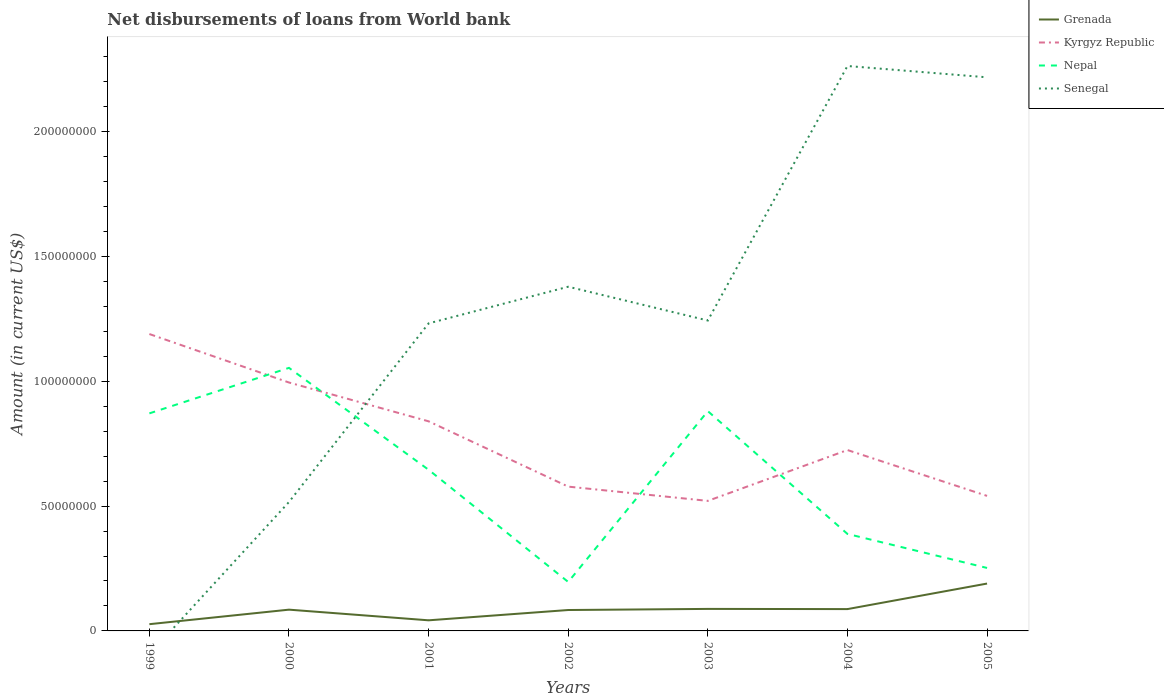Across all years, what is the maximum amount of loan disbursed from World Bank in Grenada?
Offer a very short reply. 2.70e+06. What is the total amount of loan disbursed from World Bank in Kyrgyz Republic in the graph?
Ensure brevity in your answer.  1.15e+07. What is the difference between the highest and the second highest amount of loan disbursed from World Bank in Grenada?
Offer a terse response. 1.63e+07. What is the difference between the highest and the lowest amount of loan disbursed from World Bank in Nepal?
Keep it short and to the point. 4. How many lines are there?
Ensure brevity in your answer.  4. How many years are there in the graph?
Provide a short and direct response. 7. What is the difference between two consecutive major ticks on the Y-axis?
Ensure brevity in your answer.  5.00e+07. Are the values on the major ticks of Y-axis written in scientific E-notation?
Your answer should be compact. No. Does the graph contain any zero values?
Ensure brevity in your answer.  Yes. Does the graph contain grids?
Provide a short and direct response. No. Where does the legend appear in the graph?
Offer a very short reply. Top right. How many legend labels are there?
Offer a terse response. 4. How are the legend labels stacked?
Provide a succinct answer. Vertical. What is the title of the graph?
Keep it short and to the point. Net disbursements of loans from World bank. What is the Amount (in current US$) of Grenada in 1999?
Provide a succinct answer. 2.70e+06. What is the Amount (in current US$) in Kyrgyz Republic in 1999?
Give a very brief answer. 1.19e+08. What is the Amount (in current US$) of Nepal in 1999?
Ensure brevity in your answer.  8.71e+07. What is the Amount (in current US$) in Senegal in 1999?
Your response must be concise. 0. What is the Amount (in current US$) in Grenada in 2000?
Provide a short and direct response. 8.52e+06. What is the Amount (in current US$) of Kyrgyz Republic in 2000?
Provide a succinct answer. 9.95e+07. What is the Amount (in current US$) of Nepal in 2000?
Your answer should be compact. 1.05e+08. What is the Amount (in current US$) of Senegal in 2000?
Offer a very short reply. 5.16e+07. What is the Amount (in current US$) of Grenada in 2001?
Keep it short and to the point. 4.25e+06. What is the Amount (in current US$) in Kyrgyz Republic in 2001?
Give a very brief answer. 8.40e+07. What is the Amount (in current US$) of Nepal in 2001?
Provide a succinct answer. 6.46e+07. What is the Amount (in current US$) in Senegal in 2001?
Make the answer very short. 1.23e+08. What is the Amount (in current US$) in Grenada in 2002?
Offer a terse response. 8.38e+06. What is the Amount (in current US$) of Kyrgyz Republic in 2002?
Your response must be concise. 5.78e+07. What is the Amount (in current US$) of Nepal in 2002?
Give a very brief answer. 1.96e+07. What is the Amount (in current US$) in Senegal in 2002?
Your answer should be very brief. 1.38e+08. What is the Amount (in current US$) in Grenada in 2003?
Offer a very short reply. 8.82e+06. What is the Amount (in current US$) of Kyrgyz Republic in 2003?
Your answer should be compact. 5.21e+07. What is the Amount (in current US$) in Nepal in 2003?
Your answer should be very brief. 8.80e+07. What is the Amount (in current US$) in Senegal in 2003?
Provide a short and direct response. 1.24e+08. What is the Amount (in current US$) in Grenada in 2004?
Offer a very short reply. 8.74e+06. What is the Amount (in current US$) of Kyrgyz Republic in 2004?
Ensure brevity in your answer.  7.25e+07. What is the Amount (in current US$) of Nepal in 2004?
Make the answer very short. 3.89e+07. What is the Amount (in current US$) in Senegal in 2004?
Give a very brief answer. 2.26e+08. What is the Amount (in current US$) of Grenada in 2005?
Provide a succinct answer. 1.90e+07. What is the Amount (in current US$) of Kyrgyz Republic in 2005?
Provide a succinct answer. 5.41e+07. What is the Amount (in current US$) of Nepal in 2005?
Your answer should be very brief. 2.52e+07. What is the Amount (in current US$) of Senegal in 2005?
Make the answer very short. 2.22e+08. Across all years, what is the maximum Amount (in current US$) of Grenada?
Keep it short and to the point. 1.90e+07. Across all years, what is the maximum Amount (in current US$) in Kyrgyz Republic?
Offer a very short reply. 1.19e+08. Across all years, what is the maximum Amount (in current US$) of Nepal?
Your answer should be compact. 1.05e+08. Across all years, what is the maximum Amount (in current US$) in Senegal?
Ensure brevity in your answer.  2.26e+08. Across all years, what is the minimum Amount (in current US$) of Grenada?
Give a very brief answer. 2.70e+06. Across all years, what is the minimum Amount (in current US$) in Kyrgyz Republic?
Your answer should be very brief. 5.21e+07. Across all years, what is the minimum Amount (in current US$) in Nepal?
Your response must be concise. 1.96e+07. What is the total Amount (in current US$) of Grenada in the graph?
Keep it short and to the point. 6.04e+07. What is the total Amount (in current US$) of Kyrgyz Republic in the graph?
Provide a short and direct response. 5.39e+08. What is the total Amount (in current US$) in Nepal in the graph?
Provide a short and direct response. 4.29e+08. What is the total Amount (in current US$) in Senegal in the graph?
Provide a short and direct response. 8.85e+08. What is the difference between the Amount (in current US$) in Grenada in 1999 and that in 2000?
Offer a very short reply. -5.82e+06. What is the difference between the Amount (in current US$) of Kyrgyz Republic in 1999 and that in 2000?
Offer a very short reply. 1.94e+07. What is the difference between the Amount (in current US$) of Nepal in 1999 and that in 2000?
Provide a short and direct response. -1.82e+07. What is the difference between the Amount (in current US$) of Grenada in 1999 and that in 2001?
Ensure brevity in your answer.  -1.55e+06. What is the difference between the Amount (in current US$) of Kyrgyz Republic in 1999 and that in 2001?
Make the answer very short. 3.50e+07. What is the difference between the Amount (in current US$) in Nepal in 1999 and that in 2001?
Ensure brevity in your answer.  2.26e+07. What is the difference between the Amount (in current US$) in Grenada in 1999 and that in 2002?
Give a very brief answer. -5.67e+06. What is the difference between the Amount (in current US$) in Kyrgyz Republic in 1999 and that in 2002?
Your response must be concise. 6.11e+07. What is the difference between the Amount (in current US$) in Nepal in 1999 and that in 2002?
Offer a very short reply. 6.75e+07. What is the difference between the Amount (in current US$) of Grenada in 1999 and that in 2003?
Provide a succinct answer. -6.12e+06. What is the difference between the Amount (in current US$) of Kyrgyz Republic in 1999 and that in 2003?
Your response must be concise. 6.68e+07. What is the difference between the Amount (in current US$) in Nepal in 1999 and that in 2003?
Give a very brief answer. -8.96e+05. What is the difference between the Amount (in current US$) in Grenada in 1999 and that in 2004?
Your answer should be compact. -6.04e+06. What is the difference between the Amount (in current US$) in Kyrgyz Republic in 1999 and that in 2004?
Keep it short and to the point. 4.65e+07. What is the difference between the Amount (in current US$) of Nepal in 1999 and that in 2004?
Your response must be concise. 4.83e+07. What is the difference between the Amount (in current US$) of Grenada in 1999 and that in 2005?
Your answer should be very brief. -1.63e+07. What is the difference between the Amount (in current US$) in Kyrgyz Republic in 1999 and that in 2005?
Offer a very short reply. 6.48e+07. What is the difference between the Amount (in current US$) in Nepal in 1999 and that in 2005?
Make the answer very short. 6.19e+07. What is the difference between the Amount (in current US$) of Grenada in 2000 and that in 2001?
Your response must be concise. 4.27e+06. What is the difference between the Amount (in current US$) of Kyrgyz Republic in 2000 and that in 2001?
Your response must be concise. 1.55e+07. What is the difference between the Amount (in current US$) of Nepal in 2000 and that in 2001?
Your answer should be compact. 4.08e+07. What is the difference between the Amount (in current US$) in Senegal in 2000 and that in 2001?
Your response must be concise. -7.16e+07. What is the difference between the Amount (in current US$) in Grenada in 2000 and that in 2002?
Make the answer very short. 1.44e+05. What is the difference between the Amount (in current US$) of Kyrgyz Republic in 2000 and that in 2002?
Your answer should be very brief. 4.17e+07. What is the difference between the Amount (in current US$) of Nepal in 2000 and that in 2002?
Ensure brevity in your answer.  8.58e+07. What is the difference between the Amount (in current US$) of Senegal in 2000 and that in 2002?
Offer a very short reply. -8.62e+07. What is the difference between the Amount (in current US$) in Grenada in 2000 and that in 2003?
Offer a very short reply. -2.98e+05. What is the difference between the Amount (in current US$) in Kyrgyz Republic in 2000 and that in 2003?
Offer a very short reply. 4.74e+07. What is the difference between the Amount (in current US$) of Nepal in 2000 and that in 2003?
Give a very brief answer. 1.73e+07. What is the difference between the Amount (in current US$) of Senegal in 2000 and that in 2003?
Offer a very short reply. -7.27e+07. What is the difference between the Amount (in current US$) in Grenada in 2000 and that in 2004?
Offer a terse response. -2.22e+05. What is the difference between the Amount (in current US$) in Kyrgyz Republic in 2000 and that in 2004?
Give a very brief answer. 2.70e+07. What is the difference between the Amount (in current US$) of Nepal in 2000 and that in 2004?
Provide a short and direct response. 6.65e+07. What is the difference between the Amount (in current US$) in Senegal in 2000 and that in 2004?
Ensure brevity in your answer.  -1.75e+08. What is the difference between the Amount (in current US$) of Grenada in 2000 and that in 2005?
Make the answer very short. -1.05e+07. What is the difference between the Amount (in current US$) of Kyrgyz Republic in 2000 and that in 2005?
Your answer should be very brief. 4.54e+07. What is the difference between the Amount (in current US$) of Nepal in 2000 and that in 2005?
Offer a very short reply. 8.02e+07. What is the difference between the Amount (in current US$) in Senegal in 2000 and that in 2005?
Offer a very short reply. -1.70e+08. What is the difference between the Amount (in current US$) of Grenada in 2001 and that in 2002?
Your answer should be compact. -4.12e+06. What is the difference between the Amount (in current US$) in Kyrgyz Republic in 2001 and that in 2002?
Keep it short and to the point. 2.62e+07. What is the difference between the Amount (in current US$) in Nepal in 2001 and that in 2002?
Your response must be concise. 4.49e+07. What is the difference between the Amount (in current US$) of Senegal in 2001 and that in 2002?
Provide a succinct answer. -1.47e+07. What is the difference between the Amount (in current US$) of Grenada in 2001 and that in 2003?
Your answer should be very brief. -4.57e+06. What is the difference between the Amount (in current US$) in Kyrgyz Republic in 2001 and that in 2003?
Offer a terse response. 3.19e+07. What is the difference between the Amount (in current US$) in Nepal in 2001 and that in 2003?
Your answer should be very brief. -2.35e+07. What is the difference between the Amount (in current US$) in Senegal in 2001 and that in 2003?
Provide a succinct answer. -1.15e+06. What is the difference between the Amount (in current US$) of Grenada in 2001 and that in 2004?
Your answer should be very brief. -4.49e+06. What is the difference between the Amount (in current US$) in Kyrgyz Republic in 2001 and that in 2004?
Your response must be concise. 1.15e+07. What is the difference between the Amount (in current US$) of Nepal in 2001 and that in 2004?
Provide a short and direct response. 2.57e+07. What is the difference between the Amount (in current US$) in Senegal in 2001 and that in 2004?
Ensure brevity in your answer.  -1.03e+08. What is the difference between the Amount (in current US$) of Grenada in 2001 and that in 2005?
Your answer should be very brief. -1.47e+07. What is the difference between the Amount (in current US$) of Kyrgyz Republic in 2001 and that in 2005?
Your response must be concise. 2.99e+07. What is the difference between the Amount (in current US$) of Nepal in 2001 and that in 2005?
Your response must be concise. 3.93e+07. What is the difference between the Amount (in current US$) of Senegal in 2001 and that in 2005?
Provide a short and direct response. -9.86e+07. What is the difference between the Amount (in current US$) in Grenada in 2002 and that in 2003?
Offer a very short reply. -4.42e+05. What is the difference between the Amount (in current US$) of Kyrgyz Republic in 2002 and that in 2003?
Give a very brief answer. 5.71e+06. What is the difference between the Amount (in current US$) of Nepal in 2002 and that in 2003?
Your response must be concise. -6.84e+07. What is the difference between the Amount (in current US$) in Senegal in 2002 and that in 2003?
Provide a short and direct response. 1.35e+07. What is the difference between the Amount (in current US$) of Grenada in 2002 and that in 2004?
Offer a very short reply. -3.66e+05. What is the difference between the Amount (in current US$) in Kyrgyz Republic in 2002 and that in 2004?
Ensure brevity in your answer.  -1.47e+07. What is the difference between the Amount (in current US$) in Nepal in 2002 and that in 2004?
Give a very brief answer. -1.92e+07. What is the difference between the Amount (in current US$) of Senegal in 2002 and that in 2004?
Ensure brevity in your answer.  -8.84e+07. What is the difference between the Amount (in current US$) of Grenada in 2002 and that in 2005?
Your response must be concise. -1.06e+07. What is the difference between the Amount (in current US$) of Kyrgyz Republic in 2002 and that in 2005?
Offer a terse response. 3.71e+06. What is the difference between the Amount (in current US$) in Nepal in 2002 and that in 2005?
Make the answer very short. -5.61e+06. What is the difference between the Amount (in current US$) in Senegal in 2002 and that in 2005?
Keep it short and to the point. -8.39e+07. What is the difference between the Amount (in current US$) in Grenada in 2003 and that in 2004?
Keep it short and to the point. 7.60e+04. What is the difference between the Amount (in current US$) of Kyrgyz Republic in 2003 and that in 2004?
Make the answer very short. -2.04e+07. What is the difference between the Amount (in current US$) in Nepal in 2003 and that in 2004?
Offer a terse response. 4.92e+07. What is the difference between the Amount (in current US$) in Senegal in 2003 and that in 2004?
Offer a very short reply. -1.02e+08. What is the difference between the Amount (in current US$) of Grenada in 2003 and that in 2005?
Your answer should be compact. -1.02e+07. What is the difference between the Amount (in current US$) of Kyrgyz Republic in 2003 and that in 2005?
Make the answer very short. -2.00e+06. What is the difference between the Amount (in current US$) in Nepal in 2003 and that in 2005?
Offer a very short reply. 6.28e+07. What is the difference between the Amount (in current US$) in Senegal in 2003 and that in 2005?
Make the answer very short. -9.74e+07. What is the difference between the Amount (in current US$) of Grenada in 2004 and that in 2005?
Give a very brief answer. -1.02e+07. What is the difference between the Amount (in current US$) of Kyrgyz Republic in 2004 and that in 2005?
Your answer should be very brief. 1.84e+07. What is the difference between the Amount (in current US$) in Nepal in 2004 and that in 2005?
Offer a very short reply. 1.36e+07. What is the difference between the Amount (in current US$) of Senegal in 2004 and that in 2005?
Your answer should be very brief. 4.54e+06. What is the difference between the Amount (in current US$) in Grenada in 1999 and the Amount (in current US$) in Kyrgyz Republic in 2000?
Ensure brevity in your answer.  -9.68e+07. What is the difference between the Amount (in current US$) in Grenada in 1999 and the Amount (in current US$) in Nepal in 2000?
Provide a short and direct response. -1.03e+08. What is the difference between the Amount (in current US$) of Grenada in 1999 and the Amount (in current US$) of Senegal in 2000?
Make the answer very short. -4.89e+07. What is the difference between the Amount (in current US$) in Kyrgyz Republic in 1999 and the Amount (in current US$) in Nepal in 2000?
Your answer should be very brief. 1.35e+07. What is the difference between the Amount (in current US$) in Kyrgyz Republic in 1999 and the Amount (in current US$) in Senegal in 2000?
Your response must be concise. 6.73e+07. What is the difference between the Amount (in current US$) in Nepal in 1999 and the Amount (in current US$) in Senegal in 2000?
Keep it short and to the point. 3.55e+07. What is the difference between the Amount (in current US$) of Grenada in 1999 and the Amount (in current US$) of Kyrgyz Republic in 2001?
Offer a very short reply. -8.13e+07. What is the difference between the Amount (in current US$) of Grenada in 1999 and the Amount (in current US$) of Nepal in 2001?
Provide a succinct answer. -6.19e+07. What is the difference between the Amount (in current US$) in Grenada in 1999 and the Amount (in current US$) in Senegal in 2001?
Offer a very short reply. -1.20e+08. What is the difference between the Amount (in current US$) in Kyrgyz Republic in 1999 and the Amount (in current US$) in Nepal in 2001?
Your answer should be compact. 5.44e+07. What is the difference between the Amount (in current US$) in Kyrgyz Republic in 1999 and the Amount (in current US$) in Senegal in 2001?
Keep it short and to the point. -4.27e+06. What is the difference between the Amount (in current US$) in Nepal in 1999 and the Amount (in current US$) in Senegal in 2001?
Ensure brevity in your answer.  -3.61e+07. What is the difference between the Amount (in current US$) of Grenada in 1999 and the Amount (in current US$) of Kyrgyz Republic in 2002?
Offer a terse response. -5.51e+07. What is the difference between the Amount (in current US$) of Grenada in 1999 and the Amount (in current US$) of Nepal in 2002?
Provide a short and direct response. -1.69e+07. What is the difference between the Amount (in current US$) of Grenada in 1999 and the Amount (in current US$) of Senegal in 2002?
Your answer should be very brief. -1.35e+08. What is the difference between the Amount (in current US$) of Kyrgyz Republic in 1999 and the Amount (in current US$) of Nepal in 2002?
Provide a succinct answer. 9.93e+07. What is the difference between the Amount (in current US$) of Kyrgyz Republic in 1999 and the Amount (in current US$) of Senegal in 2002?
Ensure brevity in your answer.  -1.90e+07. What is the difference between the Amount (in current US$) of Nepal in 1999 and the Amount (in current US$) of Senegal in 2002?
Give a very brief answer. -5.07e+07. What is the difference between the Amount (in current US$) in Grenada in 1999 and the Amount (in current US$) in Kyrgyz Republic in 2003?
Ensure brevity in your answer.  -4.94e+07. What is the difference between the Amount (in current US$) of Grenada in 1999 and the Amount (in current US$) of Nepal in 2003?
Your answer should be compact. -8.53e+07. What is the difference between the Amount (in current US$) of Grenada in 1999 and the Amount (in current US$) of Senegal in 2003?
Ensure brevity in your answer.  -1.22e+08. What is the difference between the Amount (in current US$) in Kyrgyz Republic in 1999 and the Amount (in current US$) in Nepal in 2003?
Provide a short and direct response. 3.09e+07. What is the difference between the Amount (in current US$) of Kyrgyz Republic in 1999 and the Amount (in current US$) of Senegal in 2003?
Offer a very short reply. -5.42e+06. What is the difference between the Amount (in current US$) in Nepal in 1999 and the Amount (in current US$) in Senegal in 2003?
Offer a very short reply. -3.72e+07. What is the difference between the Amount (in current US$) of Grenada in 1999 and the Amount (in current US$) of Kyrgyz Republic in 2004?
Offer a terse response. -6.98e+07. What is the difference between the Amount (in current US$) of Grenada in 1999 and the Amount (in current US$) of Nepal in 2004?
Your response must be concise. -3.62e+07. What is the difference between the Amount (in current US$) in Grenada in 1999 and the Amount (in current US$) in Senegal in 2004?
Ensure brevity in your answer.  -2.24e+08. What is the difference between the Amount (in current US$) in Kyrgyz Republic in 1999 and the Amount (in current US$) in Nepal in 2004?
Offer a terse response. 8.01e+07. What is the difference between the Amount (in current US$) of Kyrgyz Republic in 1999 and the Amount (in current US$) of Senegal in 2004?
Offer a terse response. -1.07e+08. What is the difference between the Amount (in current US$) of Nepal in 1999 and the Amount (in current US$) of Senegal in 2004?
Your answer should be very brief. -1.39e+08. What is the difference between the Amount (in current US$) in Grenada in 1999 and the Amount (in current US$) in Kyrgyz Republic in 2005?
Keep it short and to the point. -5.14e+07. What is the difference between the Amount (in current US$) in Grenada in 1999 and the Amount (in current US$) in Nepal in 2005?
Provide a succinct answer. -2.25e+07. What is the difference between the Amount (in current US$) of Grenada in 1999 and the Amount (in current US$) of Senegal in 2005?
Offer a terse response. -2.19e+08. What is the difference between the Amount (in current US$) in Kyrgyz Republic in 1999 and the Amount (in current US$) in Nepal in 2005?
Make the answer very short. 9.37e+07. What is the difference between the Amount (in current US$) of Kyrgyz Republic in 1999 and the Amount (in current US$) of Senegal in 2005?
Your response must be concise. -1.03e+08. What is the difference between the Amount (in current US$) of Nepal in 1999 and the Amount (in current US$) of Senegal in 2005?
Offer a terse response. -1.35e+08. What is the difference between the Amount (in current US$) in Grenada in 2000 and the Amount (in current US$) in Kyrgyz Republic in 2001?
Provide a short and direct response. -7.54e+07. What is the difference between the Amount (in current US$) in Grenada in 2000 and the Amount (in current US$) in Nepal in 2001?
Give a very brief answer. -5.60e+07. What is the difference between the Amount (in current US$) of Grenada in 2000 and the Amount (in current US$) of Senegal in 2001?
Give a very brief answer. -1.15e+08. What is the difference between the Amount (in current US$) in Kyrgyz Republic in 2000 and the Amount (in current US$) in Nepal in 2001?
Your response must be concise. 3.50e+07. What is the difference between the Amount (in current US$) in Kyrgyz Republic in 2000 and the Amount (in current US$) in Senegal in 2001?
Provide a succinct answer. -2.37e+07. What is the difference between the Amount (in current US$) in Nepal in 2000 and the Amount (in current US$) in Senegal in 2001?
Your answer should be compact. -1.78e+07. What is the difference between the Amount (in current US$) of Grenada in 2000 and the Amount (in current US$) of Kyrgyz Republic in 2002?
Your answer should be very brief. -4.93e+07. What is the difference between the Amount (in current US$) of Grenada in 2000 and the Amount (in current US$) of Nepal in 2002?
Keep it short and to the point. -1.11e+07. What is the difference between the Amount (in current US$) of Grenada in 2000 and the Amount (in current US$) of Senegal in 2002?
Offer a very short reply. -1.29e+08. What is the difference between the Amount (in current US$) of Kyrgyz Republic in 2000 and the Amount (in current US$) of Nepal in 2002?
Keep it short and to the point. 7.99e+07. What is the difference between the Amount (in current US$) in Kyrgyz Republic in 2000 and the Amount (in current US$) in Senegal in 2002?
Make the answer very short. -3.84e+07. What is the difference between the Amount (in current US$) in Nepal in 2000 and the Amount (in current US$) in Senegal in 2002?
Your response must be concise. -3.25e+07. What is the difference between the Amount (in current US$) of Grenada in 2000 and the Amount (in current US$) of Kyrgyz Republic in 2003?
Give a very brief answer. -4.36e+07. What is the difference between the Amount (in current US$) of Grenada in 2000 and the Amount (in current US$) of Nepal in 2003?
Your answer should be very brief. -7.95e+07. What is the difference between the Amount (in current US$) in Grenada in 2000 and the Amount (in current US$) in Senegal in 2003?
Offer a terse response. -1.16e+08. What is the difference between the Amount (in current US$) of Kyrgyz Republic in 2000 and the Amount (in current US$) of Nepal in 2003?
Provide a short and direct response. 1.15e+07. What is the difference between the Amount (in current US$) of Kyrgyz Republic in 2000 and the Amount (in current US$) of Senegal in 2003?
Offer a very short reply. -2.48e+07. What is the difference between the Amount (in current US$) in Nepal in 2000 and the Amount (in current US$) in Senegal in 2003?
Offer a very short reply. -1.90e+07. What is the difference between the Amount (in current US$) in Grenada in 2000 and the Amount (in current US$) in Kyrgyz Republic in 2004?
Ensure brevity in your answer.  -6.39e+07. What is the difference between the Amount (in current US$) of Grenada in 2000 and the Amount (in current US$) of Nepal in 2004?
Your answer should be very brief. -3.03e+07. What is the difference between the Amount (in current US$) of Grenada in 2000 and the Amount (in current US$) of Senegal in 2004?
Provide a succinct answer. -2.18e+08. What is the difference between the Amount (in current US$) of Kyrgyz Republic in 2000 and the Amount (in current US$) of Nepal in 2004?
Offer a very short reply. 6.07e+07. What is the difference between the Amount (in current US$) of Kyrgyz Republic in 2000 and the Amount (in current US$) of Senegal in 2004?
Offer a terse response. -1.27e+08. What is the difference between the Amount (in current US$) in Nepal in 2000 and the Amount (in current US$) in Senegal in 2004?
Offer a terse response. -1.21e+08. What is the difference between the Amount (in current US$) in Grenada in 2000 and the Amount (in current US$) in Kyrgyz Republic in 2005?
Give a very brief answer. -4.56e+07. What is the difference between the Amount (in current US$) in Grenada in 2000 and the Amount (in current US$) in Nepal in 2005?
Your answer should be very brief. -1.67e+07. What is the difference between the Amount (in current US$) of Grenada in 2000 and the Amount (in current US$) of Senegal in 2005?
Provide a short and direct response. -2.13e+08. What is the difference between the Amount (in current US$) in Kyrgyz Republic in 2000 and the Amount (in current US$) in Nepal in 2005?
Provide a short and direct response. 7.43e+07. What is the difference between the Amount (in current US$) of Kyrgyz Republic in 2000 and the Amount (in current US$) of Senegal in 2005?
Provide a succinct answer. -1.22e+08. What is the difference between the Amount (in current US$) in Nepal in 2000 and the Amount (in current US$) in Senegal in 2005?
Offer a very short reply. -1.16e+08. What is the difference between the Amount (in current US$) of Grenada in 2001 and the Amount (in current US$) of Kyrgyz Republic in 2002?
Offer a terse response. -5.36e+07. What is the difference between the Amount (in current US$) in Grenada in 2001 and the Amount (in current US$) in Nepal in 2002?
Your answer should be compact. -1.54e+07. What is the difference between the Amount (in current US$) in Grenada in 2001 and the Amount (in current US$) in Senegal in 2002?
Offer a terse response. -1.34e+08. What is the difference between the Amount (in current US$) in Kyrgyz Republic in 2001 and the Amount (in current US$) in Nepal in 2002?
Provide a short and direct response. 6.43e+07. What is the difference between the Amount (in current US$) in Kyrgyz Republic in 2001 and the Amount (in current US$) in Senegal in 2002?
Your response must be concise. -5.39e+07. What is the difference between the Amount (in current US$) in Nepal in 2001 and the Amount (in current US$) in Senegal in 2002?
Offer a very short reply. -7.33e+07. What is the difference between the Amount (in current US$) in Grenada in 2001 and the Amount (in current US$) in Kyrgyz Republic in 2003?
Provide a short and direct response. -4.78e+07. What is the difference between the Amount (in current US$) in Grenada in 2001 and the Amount (in current US$) in Nepal in 2003?
Provide a succinct answer. -8.38e+07. What is the difference between the Amount (in current US$) of Grenada in 2001 and the Amount (in current US$) of Senegal in 2003?
Ensure brevity in your answer.  -1.20e+08. What is the difference between the Amount (in current US$) in Kyrgyz Republic in 2001 and the Amount (in current US$) in Nepal in 2003?
Provide a succinct answer. -4.08e+06. What is the difference between the Amount (in current US$) in Kyrgyz Republic in 2001 and the Amount (in current US$) in Senegal in 2003?
Ensure brevity in your answer.  -4.04e+07. What is the difference between the Amount (in current US$) of Nepal in 2001 and the Amount (in current US$) of Senegal in 2003?
Ensure brevity in your answer.  -5.98e+07. What is the difference between the Amount (in current US$) of Grenada in 2001 and the Amount (in current US$) of Kyrgyz Republic in 2004?
Your answer should be very brief. -6.82e+07. What is the difference between the Amount (in current US$) in Grenada in 2001 and the Amount (in current US$) in Nepal in 2004?
Your response must be concise. -3.46e+07. What is the difference between the Amount (in current US$) of Grenada in 2001 and the Amount (in current US$) of Senegal in 2004?
Keep it short and to the point. -2.22e+08. What is the difference between the Amount (in current US$) in Kyrgyz Republic in 2001 and the Amount (in current US$) in Nepal in 2004?
Provide a succinct answer. 4.51e+07. What is the difference between the Amount (in current US$) in Kyrgyz Republic in 2001 and the Amount (in current US$) in Senegal in 2004?
Offer a very short reply. -1.42e+08. What is the difference between the Amount (in current US$) in Nepal in 2001 and the Amount (in current US$) in Senegal in 2004?
Your response must be concise. -1.62e+08. What is the difference between the Amount (in current US$) of Grenada in 2001 and the Amount (in current US$) of Kyrgyz Republic in 2005?
Provide a succinct answer. -4.98e+07. What is the difference between the Amount (in current US$) of Grenada in 2001 and the Amount (in current US$) of Nepal in 2005?
Provide a short and direct response. -2.10e+07. What is the difference between the Amount (in current US$) of Grenada in 2001 and the Amount (in current US$) of Senegal in 2005?
Your answer should be very brief. -2.18e+08. What is the difference between the Amount (in current US$) of Kyrgyz Republic in 2001 and the Amount (in current US$) of Nepal in 2005?
Keep it short and to the point. 5.87e+07. What is the difference between the Amount (in current US$) in Kyrgyz Republic in 2001 and the Amount (in current US$) in Senegal in 2005?
Make the answer very short. -1.38e+08. What is the difference between the Amount (in current US$) in Nepal in 2001 and the Amount (in current US$) in Senegal in 2005?
Provide a short and direct response. -1.57e+08. What is the difference between the Amount (in current US$) in Grenada in 2002 and the Amount (in current US$) in Kyrgyz Republic in 2003?
Make the answer very short. -4.37e+07. What is the difference between the Amount (in current US$) in Grenada in 2002 and the Amount (in current US$) in Nepal in 2003?
Keep it short and to the point. -7.97e+07. What is the difference between the Amount (in current US$) in Grenada in 2002 and the Amount (in current US$) in Senegal in 2003?
Offer a terse response. -1.16e+08. What is the difference between the Amount (in current US$) in Kyrgyz Republic in 2002 and the Amount (in current US$) in Nepal in 2003?
Offer a terse response. -3.02e+07. What is the difference between the Amount (in current US$) in Kyrgyz Republic in 2002 and the Amount (in current US$) in Senegal in 2003?
Ensure brevity in your answer.  -6.65e+07. What is the difference between the Amount (in current US$) of Nepal in 2002 and the Amount (in current US$) of Senegal in 2003?
Your response must be concise. -1.05e+08. What is the difference between the Amount (in current US$) in Grenada in 2002 and the Amount (in current US$) in Kyrgyz Republic in 2004?
Provide a short and direct response. -6.41e+07. What is the difference between the Amount (in current US$) of Grenada in 2002 and the Amount (in current US$) of Nepal in 2004?
Your response must be concise. -3.05e+07. What is the difference between the Amount (in current US$) in Grenada in 2002 and the Amount (in current US$) in Senegal in 2004?
Your answer should be very brief. -2.18e+08. What is the difference between the Amount (in current US$) in Kyrgyz Republic in 2002 and the Amount (in current US$) in Nepal in 2004?
Provide a succinct answer. 1.89e+07. What is the difference between the Amount (in current US$) of Kyrgyz Republic in 2002 and the Amount (in current US$) of Senegal in 2004?
Give a very brief answer. -1.69e+08. What is the difference between the Amount (in current US$) in Nepal in 2002 and the Amount (in current US$) in Senegal in 2004?
Your answer should be compact. -2.07e+08. What is the difference between the Amount (in current US$) of Grenada in 2002 and the Amount (in current US$) of Kyrgyz Republic in 2005?
Provide a short and direct response. -4.57e+07. What is the difference between the Amount (in current US$) in Grenada in 2002 and the Amount (in current US$) in Nepal in 2005?
Your response must be concise. -1.68e+07. What is the difference between the Amount (in current US$) in Grenada in 2002 and the Amount (in current US$) in Senegal in 2005?
Your answer should be very brief. -2.13e+08. What is the difference between the Amount (in current US$) of Kyrgyz Republic in 2002 and the Amount (in current US$) of Nepal in 2005?
Your response must be concise. 3.26e+07. What is the difference between the Amount (in current US$) in Kyrgyz Republic in 2002 and the Amount (in current US$) in Senegal in 2005?
Offer a terse response. -1.64e+08. What is the difference between the Amount (in current US$) of Nepal in 2002 and the Amount (in current US$) of Senegal in 2005?
Offer a very short reply. -2.02e+08. What is the difference between the Amount (in current US$) in Grenada in 2003 and the Amount (in current US$) in Kyrgyz Republic in 2004?
Your answer should be compact. -6.36e+07. What is the difference between the Amount (in current US$) in Grenada in 2003 and the Amount (in current US$) in Nepal in 2004?
Your answer should be very brief. -3.00e+07. What is the difference between the Amount (in current US$) of Grenada in 2003 and the Amount (in current US$) of Senegal in 2004?
Your response must be concise. -2.17e+08. What is the difference between the Amount (in current US$) of Kyrgyz Republic in 2003 and the Amount (in current US$) of Nepal in 2004?
Offer a terse response. 1.32e+07. What is the difference between the Amount (in current US$) in Kyrgyz Republic in 2003 and the Amount (in current US$) in Senegal in 2004?
Keep it short and to the point. -1.74e+08. What is the difference between the Amount (in current US$) of Nepal in 2003 and the Amount (in current US$) of Senegal in 2004?
Your response must be concise. -1.38e+08. What is the difference between the Amount (in current US$) in Grenada in 2003 and the Amount (in current US$) in Kyrgyz Republic in 2005?
Keep it short and to the point. -4.53e+07. What is the difference between the Amount (in current US$) of Grenada in 2003 and the Amount (in current US$) of Nepal in 2005?
Give a very brief answer. -1.64e+07. What is the difference between the Amount (in current US$) of Grenada in 2003 and the Amount (in current US$) of Senegal in 2005?
Your response must be concise. -2.13e+08. What is the difference between the Amount (in current US$) of Kyrgyz Republic in 2003 and the Amount (in current US$) of Nepal in 2005?
Make the answer very short. 2.69e+07. What is the difference between the Amount (in current US$) in Kyrgyz Republic in 2003 and the Amount (in current US$) in Senegal in 2005?
Make the answer very short. -1.70e+08. What is the difference between the Amount (in current US$) in Nepal in 2003 and the Amount (in current US$) in Senegal in 2005?
Ensure brevity in your answer.  -1.34e+08. What is the difference between the Amount (in current US$) of Grenada in 2004 and the Amount (in current US$) of Kyrgyz Republic in 2005?
Provide a short and direct response. -4.54e+07. What is the difference between the Amount (in current US$) of Grenada in 2004 and the Amount (in current US$) of Nepal in 2005?
Your response must be concise. -1.65e+07. What is the difference between the Amount (in current US$) of Grenada in 2004 and the Amount (in current US$) of Senegal in 2005?
Ensure brevity in your answer.  -2.13e+08. What is the difference between the Amount (in current US$) of Kyrgyz Republic in 2004 and the Amount (in current US$) of Nepal in 2005?
Give a very brief answer. 4.72e+07. What is the difference between the Amount (in current US$) in Kyrgyz Republic in 2004 and the Amount (in current US$) in Senegal in 2005?
Your answer should be compact. -1.49e+08. What is the difference between the Amount (in current US$) in Nepal in 2004 and the Amount (in current US$) in Senegal in 2005?
Provide a succinct answer. -1.83e+08. What is the average Amount (in current US$) of Grenada per year?
Offer a very short reply. 8.63e+06. What is the average Amount (in current US$) in Kyrgyz Republic per year?
Your response must be concise. 7.70e+07. What is the average Amount (in current US$) in Nepal per year?
Ensure brevity in your answer.  6.13e+07. What is the average Amount (in current US$) in Senegal per year?
Keep it short and to the point. 1.26e+08. In the year 1999, what is the difference between the Amount (in current US$) in Grenada and Amount (in current US$) in Kyrgyz Republic?
Your answer should be very brief. -1.16e+08. In the year 1999, what is the difference between the Amount (in current US$) of Grenada and Amount (in current US$) of Nepal?
Provide a succinct answer. -8.44e+07. In the year 1999, what is the difference between the Amount (in current US$) in Kyrgyz Republic and Amount (in current US$) in Nepal?
Offer a very short reply. 3.18e+07. In the year 2000, what is the difference between the Amount (in current US$) of Grenada and Amount (in current US$) of Kyrgyz Republic?
Your answer should be compact. -9.10e+07. In the year 2000, what is the difference between the Amount (in current US$) in Grenada and Amount (in current US$) in Nepal?
Offer a very short reply. -9.69e+07. In the year 2000, what is the difference between the Amount (in current US$) in Grenada and Amount (in current US$) in Senegal?
Your answer should be compact. -4.31e+07. In the year 2000, what is the difference between the Amount (in current US$) of Kyrgyz Republic and Amount (in current US$) of Nepal?
Ensure brevity in your answer.  -5.87e+06. In the year 2000, what is the difference between the Amount (in current US$) in Kyrgyz Republic and Amount (in current US$) in Senegal?
Ensure brevity in your answer.  4.79e+07. In the year 2000, what is the difference between the Amount (in current US$) in Nepal and Amount (in current US$) in Senegal?
Your response must be concise. 5.37e+07. In the year 2001, what is the difference between the Amount (in current US$) of Grenada and Amount (in current US$) of Kyrgyz Republic?
Offer a very short reply. -7.97e+07. In the year 2001, what is the difference between the Amount (in current US$) in Grenada and Amount (in current US$) in Nepal?
Make the answer very short. -6.03e+07. In the year 2001, what is the difference between the Amount (in current US$) in Grenada and Amount (in current US$) in Senegal?
Make the answer very short. -1.19e+08. In the year 2001, what is the difference between the Amount (in current US$) in Kyrgyz Republic and Amount (in current US$) in Nepal?
Give a very brief answer. 1.94e+07. In the year 2001, what is the difference between the Amount (in current US$) of Kyrgyz Republic and Amount (in current US$) of Senegal?
Make the answer very short. -3.92e+07. In the year 2001, what is the difference between the Amount (in current US$) of Nepal and Amount (in current US$) of Senegal?
Offer a terse response. -5.86e+07. In the year 2002, what is the difference between the Amount (in current US$) of Grenada and Amount (in current US$) of Kyrgyz Republic?
Ensure brevity in your answer.  -4.94e+07. In the year 2002, what is the difference between the Amount (in current US$) of Grenada and Amount (in current US$) of Nepal?
Your answer should be compact. -1.12e+07. In the year 2002, what is the difference between the Amount (in current US$) of Grenada and Amount (in current US$) of Senegal?
Your response must be concise. -1.30e+08. In the year 2002, what is the difference between the Amount (in current US$) of Kyrgyz Republic and Amount (in current US$) of Nepal?
Your answer should be very brief. 3.82e+07. In the year 2002, what is the difference between the Amount (in current US$) in Kyrgyz Republic and Amount (in current US$) in Senegal?
Ensure brevity in your answer.  -8.01e+07. In the year 2002, what is the difference between the Amount (in current US$) of Nepal and Amount (in current US$) of Senegal?
Make the answer very short. -1.18e+08. In the year 2003, what is the difference between the Amount (in current US$) of Grenada and Amount (in current US$) of Kyrgyz Republic?
Your response must be concise. -4.33e+07. In the year 2003, what is the difference between the Amount (in current US$) in Grenada and Amount (in current US$) in Nepal?
Keep it short and to the point. -7.92e+07. In the year 2003, what is the difference between the Amount (in current US$) of Grenada and Amount (in current US$) of Senegal?
Offer a very short reply. -1.16e+08. In the year 2003, what is the difference between the Amount (in current US$) of Kyrgyz Republic and Amount (in current US$) of Nepal?
Keep it short and to the point. -3.59e+07. In the year 2003, what is the difference between the Amount (in current US$) of Kyrgyz Republic and Amount (in current US$) of Senegal?
Your answer should be compact. -7.23e+07. In the year 2003, what is the difference between the Amount (in current US$) of Nepal and Amount (in current US$) of Senegal?
Give a very brief answer. -3.63e+07. In the year 2004, what is the difference between the Amount (in current US$) in Grenada and Amount (in current US$) in Kyrgyz Republic?
Your response must be concise. -6.37e+07. In the year 2004, what is the difference between the Amount (in current US$) in Grenada and Amount (in current US$) in Nepal?
Your answer should be very brief. -3.01e+07. In the year 2004, what is the difference between the Amount (in current US$) of Grenada and Amount (in current US$) of Senegal?
Give a very brief answer. -2.18e+08. In the year 2004, what is the difference between the Amount (in current US$) of Kyrgyz Republic and Amount (in current US$) of Nepal?
Provide a succinct answer. 3.36e+07. In the year 2004, what is the difference between the Amount (in current US$) of Kyrgyz Republic and Amount (in current US$) of Senegal?
Make the answer very short. -1.54e+08. In the year 2004, what is the difference between the Amount (in current US$) in Nepal and Amount (in current US$) in Senegal?
Give a very brief answer. -1.87e+08. In the year 2005, what is the difference between the Amount (in current US$) in Grenada and Amount (in current US$) in Kyrgyz Republic?
Ensure brevity in your answer.  -3.51e+07. In the year 2005, what is the difference between the Amount (in current US$) in Grenada and Amount (in current US$) in Nepal?
Your answer should be very brief. -6.25e+06. In the year 2005, what is the difference between the Amount (in current US$) of Grenada and Amount (in current US$) of Senegal?
Provide a short and direct response. -2.03e+08. In the year 2005, what is the difference between the Amount (in current US$) in Kyrgyz Republic and Amount (in current US$) in Nepal?
Give a very brief answer. 2.89e+07. In the year 2005, what is the difference between the Amount (in current US$) of Kyrgyz Republic and Amount (in current US$) of Senegal?
Your answer should be very brief. -1.68e+08. In the year 2005, what is the difference between the Amount (in current US$) in Nepal and Amount (in current US$) in Senegal?
Give a very brief answer. -1.97e+08. What is the ratio of the Amount (in current US$) of Grenada in 1999 to that in 2000?
Your response must be concise. 0.32. What is the ratio of the Amount (in current US$) of Kyrgyz Republic in 1999 to that in 2000?
Your response must be concise. 1.2. What is the ratio of the Amount (in current US$) of Nepal in 1999 to that in 2000?
Offer a terse response. 0.83. What is the ratio of the Amount (in current US$) in Grenada in 1999 to that in 2001?
Your answer should be compact. 0.64. What is the ratio of the Amount (in current US$) of Kyrgyz Republic in 1999 to that in 2001?
Keep it short and to the point. 1.42. What is the ratio of the Amount (in current US$) in Nepal in 1999 to that in 2001?
Your answer should be very brief. 1.35. What is the ratio of the Amount (in current US$) of Grenada in 1999 to that in 2002?
Give a very brief answer. 0.32. What is the ratio of the Amount (in current US$) in Kyrgyz Republic in 1999 to that in 2002?
Provide a succinct answer. 2.06. What is the ratio of the Amount (in current US$) in Nepal in 1999 to that in 2002?
Make the answer very short. 4.44. What is the ratio of the Amount (in current US$) of Grenada in 1999 to that in 2003?
Offer a terse response. 0.31. What is the ratio of the Amount (in current US$) in Kyrgyz Republic in 1999 to that in 2003?
Your answer should be compact. 2.28. What is the ratio of the Amount (in current US$) of Nepal in 1999 to that in 2003?
Provide a short and direct response. 0.99. What is the ratio of the Amount (in current US$) in Grenada in 1999 to that in 2004?
Your answer should be compact. 0.31. What is the ratio of the Amount (in current US$) of Kyrgyz Republic in 1999 to that in 2004?
Offer a very short reply. 1.64. What is the ratio of the Amount (in current US$) in Nepal in 1999 to that in 2004?
Provide a succinct answer. 2.24. What is the ratio of the Amount (in current US$) in Grenada in 1999 to that in 2005?
Ensure brevity in your answer.  0.14. What is the ratio of the Amount (in current US$) of Kyrgyz Republic in 1999 to that in 2005?
Offer a very short reply. 2.2. What is the ratio of the Amount (in current US$) of Nepal in 1999 to that in 2005?
Give a very brief answer. 3.45. What is the ratio of the Amount (in current US$) of Grenada in 2000 to that in 2001?
Give a very brief answer. 2. What is the ratio of the Amount (in current US$) of Kyrgyz Republic in 2000 to that in 2001?
Ensure brevity in your answer.  1.19. What is the ratio of the Amount (in current US$) of Nepal in 2000 to that in 2001?
Offer a very short reply. 1.63. What is the ratio of the Amount (in current US$) of Senegal in 2000 to that in 2001?
Your response must be concise. 0.42. What is the ratio of the Amount (in current US$) of Grenada in 2000 to that in 2002?
Make the answer very short. 1.02. What is the ratio of the Amount (in current US$) in Kyrgyz Republic in 2000 to that in 2002?
Your answer should be very brief. 1.72. What is the ratio of the Amount (in current US$) of Nepal in 2000 to that in 2002?
Ensure brevity in your answer.  5.37. What is the ratio of the Amount (in current US$) of Senegal in 2000 to that in 2002?
Keep it short and to the point. 0.37. What is the ratio of the Amount (in current US$) of Grenada in 2000 to that in 2003?
Ensure brevity in your answer.  0.97. What is the ratio of the Amount (in current US$) in Kyrgyz Republic in 2000 to that in 2003?
Your answer should be compact. 1.91. What is the ratio of the Amount (in current US$) in Nepal in 2000 to that in 2003?
Offer a very short reply. 1.2. What is the ratio of the Amount (in current US$) of Senegal in 2000 to that in 2003?
Give a very brief answer. 0.42. What is the ratio of the Amount (in current US$) of Grenada in 2000 to that in 2004?
Ensure brevity in your answer.  0.97. What is the ratio of the Amount (in current US$) in Kyrgyz Republic in 2000 to that in 2004?
Your response must be concise. 1.37. What is the ratio of the Amount (in current US$) of Nepal in 2000 to that in 2004?
Your answer should be very brief. 2.71. What is the ratio of the Amount (in current US$) of Senegal in 2000 to that in 2004?
Your answer should be compact. 0.23. What is the ratio of the Amount (in current US$) in Grenada in 2000 to that in 2005?
Make the answer very short. 0.45. What is the ratio of the Amount (in current US$) of Kyrgyz Republic in 2000 to that in 2005?
Provide a short and direct response. 1.84. What is the ratio of the Amount (in current US$) of Nepal in 2000 to that in 2005?
Offer a very short reply. 4.18. What is the ratio of the Amount (in current US$) in Senegal in 2000 to that in 2005?
Offer a very short reply. 0.23. What is the ratio of the Amount (in current US$) in Grenada in 2001 to that in 2002?
Offer a terse response. 0.51. What is the ratio of the Amount (in current US$) in Kyrgyz Republic in 2001 to that in 2002?
Provide a short and direct response. 1.45. What is the ratio of the Amount (in current US$) in Nepal in 2001 to that in 2002?
Provide a short and direct response. 3.29. What is the ratio of the Amount (in current US$) of Senegal in 2001 to that in 2002?
Offer a terse response. 0.89. What is the ratio of the Amount (in current US$) of Grenada in 2001 to that in 2003?
Offer a terse response. 0.48. What is the ratio of the Amount (in current US$) in Kyrgyz Republic in 2001 to that in 2003?
Your response must be concise. 1.61. What is the ratio of the Amount (in current US$) in Nepal in 2001 to that in 2003?
Provide a succinct answer. 0.73. What is the ratio of the Amount (in current US$) in Grenada in 2001 to that in 2004?
Keep it short and to the point. 0.49. What is the ratio of the Amount (in current US$) in Kyrgyz Republic in 2001 to that in 2004?
Make the answer very short. 1.16. What is the ratio of the Amount (in current US$) of Nepal in 2001 to that in 2004?
Your answer should be compact. 1.66. What is the ratio of the Amount (in current US$) in Senegal in 2001 to that in 2004?
Offer a very short reply. 0.54. What is the ratio of the Amount (in current US$) in Grenada in 2001 to that in 2005?
Provide a short and direct response. 0.22. What is the ratio of the Amount (in current US$) of Kyrgyz Republic in 2001 to that in 2005?
Your response must be concise. 1.55. What is the ratio of the Amount (in current US$) of Nepal in 2001 to that in 2005?
Offer a very short reply. 2.56. What is the ratio of the Amount (in current US$) of Senegal in 2001 to that in 2005?
Give a very brief answer. 0.56. What is the ratio of the Amount (in current US$) of Grenada in 2002 to that in 2003?
Provide a succinct answer. 0.95. What is the ratio of the Amount (in current US$) in Kyrgyz Republic in 2002 to that in 2003?
Keep it short and to the point. 1.11. What is the ratio of the Amount (in current US$) in Nepal in 2002 to that in 2003?
Ensure brevity in your answer.  0.22. What is the ratio of the Amount (in current US$) in Senegal in 2002 to that in 2003?
Provide a short and direct response. 1.11. What is the ratio of the Amount (in current US$) in Grenada in 2002 to that in 2004?
Ensure brevity in your answer.  0.96. What is the ratio of the Amount (in current US$) in Kyrgyz Republic in 2002 to that in 2004?
Provide a succinct answer. 0.8. What is the ratio of the Amount (in current US$) of Nepal in 2002 to that in 2004?
Offer a very short reply. 0.5. What is the ratio of the Amount (in current US$) of Senegal in 2002 to that in 2004?
Your answer should be compact. 0.61. What is the ratio of the Amount (in current US$) in Grenada in 2002 to that in 2005?
Make the answer very short. 0.44. What is the ratio of the Amount (in current US$) in Kyrgyz Republic in 2002 to that in 2005?
Keep it short and to the point. 1.07. What is the ratio of the Amount (in current US$) of Nepal in 2002 to that in 2005?
Offer a terse response. 0.78. What is the ratio of the Amount (in current US$) in Senegal in 2002 to that in 2005?
Make the answer very short. 0.62. What is the ratio of the Amount (in current US$) of Grenada in 2003 to that in 2004?
Your answer should be very brief. 1.01. What is the ratio of the Amount (in current US$) in Kyrgyz Republic in 2003 to that in 2004?
Give a very brief answer. 0.72. What is the ratio of the Amount (in current US$) of Nepal in 2003 to that in 2004?
Provide a succinct answer. 2.27. What is the ratio of the Amount (in current US$) of Senegal in 2003 to that in 2004?
Provide a short and direct response. 0.55. What is the ratio of the Amount (in current US$) in Grenada in 2003 to that in 2005?
Keep it short and to the point. 0.46. What is the ratio of the Amount (in current US$) in Kyrgyz Republic in 2003 to that in 2005?
Keep it short and to the point. 0.96. What is the ratio of the Amount (in current US$) in Nepal in 2003 to that in 2005?
Keep it short and to the point. 3.49. What is the ratio of the Amount (in current US$) of Senegal in 2003 to that in 2005?
Keep it short and to the point. 0.56. What is the ratio of the Amount (in current US$) of Grenada in 2004 to that in 2005?
Your response must be concise. 0.46. What is the ratio of the Amount (in current US$) of Kyrgyz Republic in 2004 to that in 2005?
Your answer should be compact. 1.34. What is the ratio of the Amount (in current US$) of Nepal in 2004 to that in 2005?
Your response must be concise. 1.54. What is the ratio of the Amount (in current US$) in Senegal in 2004 to that in 2005?
Give a very brief answer. 1.02. What is the difference between the highest and the second highest Amount (in current US$) of Grenada?
Make the answer very short. 1.02e+07. What is the difference between the highest and the second highest Amount (in current US$) of Kyrgyz Republic?
Provide a succinct answer. 1.94e+07. What is the difference between the highest and the second highest Amount (in current US$) in Nepal?
Offer a very short reply. 1.73e+07. What is the difference between the highest and the second highest Amount (in current US$) in Senegal?
Your answer should be compact. 4.54e+06. What is the difference between the highest and the lowest Amount (in current US$) in Grenada?
Your answer should be compact. 1.63e+07. What is the difference between the highest and the lowest Amount (in current US$) in Kyrgyz Republic?
Your response must be concise. 6.68e+07. What is the difference between the highest and the lowest Amount (in current US$) in Nepal?
Offer a terse response. 8.58e+07. What is the difference between the highest and the lowest Amount (in current US$) in Senegal?
Offer a very short reply. 2.26e+08. 